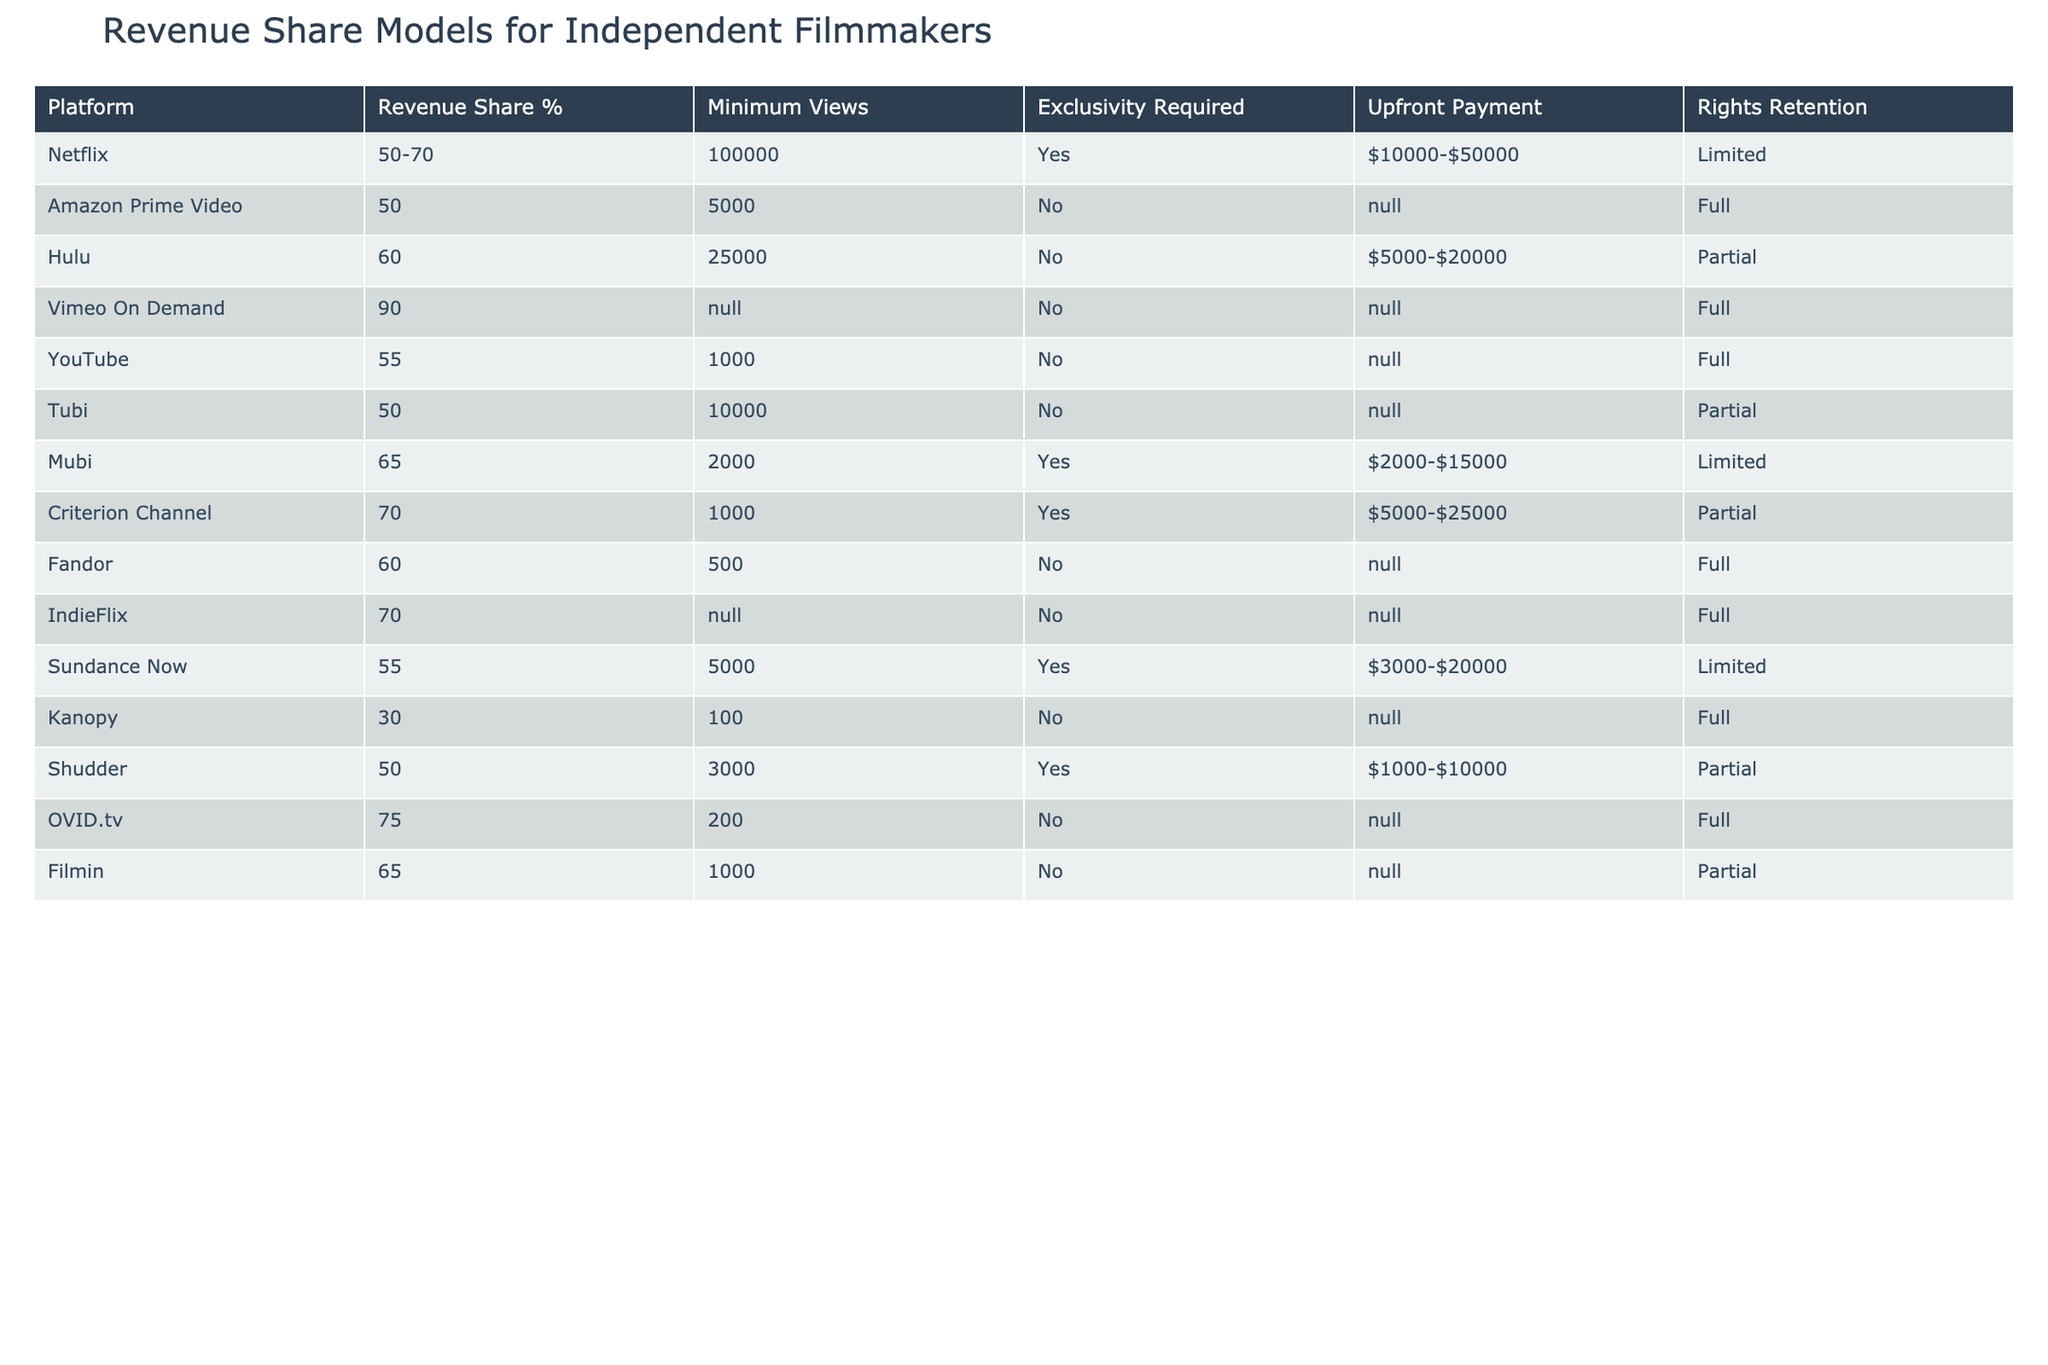What is the revenue share percentage for Vimeo On Demand? In the table, I look for the row that corresponds to Vimeo On Demand and find the "Revenue Share %" column. It shows 90%.
Answer: 90% Is there a platform that offers a revenue share of 70%? By scanning through the "Revenue Share %" column, I see that both Netflix and IndieFlix offer a revenue share of 70%.
Answer: Yes Which platform requires exclusivity for revenue sharing? I check the "Exclusivity Required" column for all platforms. The platforms that have 'Yes' listed there are Netflix, Mubi, Criterion Channel, and Sundance Now.
Answer: Netflix, Mubi, Criterion Channel, Sundance Now What is the minimum number of views required on YouTube for revenue sharing? Looking at YouTube's row in the table, the "Minimum Views" column shows 1000 views are required.
Answer: 1000 Are there any platforms that provide full rights retention to filmmakers? I examine the "Rights Retention" column and find that Amazon Prime Video, Vimeo On Demand, YouTube, Fandor, and IndieFlix all have 'Full' listed as their rights retention policy.
Answer: Yes What is the average revenue share percentage of platforms that do not require exclusivity? I identify the platforms not requiring exclusivity: Amazon Prime Video (50%), Hulu (60%), Vimeo On Demand (90%), YouTube (55%), Tubi (50%), Fandor (60%), IndieFlix (70%), and Kanopy (30%). I sum these percentages: 50 + 60 + 90 + 55 + 50 + 60 + 70 + 30 = 415. There are 8 platforms, so the average is 415/8 = 51.875, which rounds to 52%.
Answer: 52% How many platforms have a minimum view count of 5,000 or more? I count the platforms with "Minimum Views" equal to or exceeding 5,000. These are Netflix (100,000), Hulu (25,000), Amazon Prime Video (5,000), Mubi (2,000), Sundance Now (5,000), Shudder (3,000). Adding these gives 6 platforms.
Answer: 6 Which platform offers the highest upfront payment to filmmakers? In the "Upfront Payment" column, I compare all values and determine that Netflix offers $10,000-$50,000, while Criterion Channel has $5,000-$25,000. The highest range belongs to Netflix.
Answer: Netflix Is there any platform that does not require any minimum views for revenue sharing? Looking at the "Minimum Views" column, I find that both Vimeo On Demand and IndieFlix have 'None' specified, which means no minimum views are required.
Answer: Yes What is the difference in revenue share percentage between the highest and the lowest platform? The highest revenue share percentage is 90% (Vimeo On Demand) and the lowest is 30% (Kanopy). The difference is 90 - 30 = 60%.
Answer: 60% What percentage of platforms require an upfront payment? I scan through the "Upfront Payment" column and see that 6 out of 12 platforms list specific upfront payment ranges (i.e., Netflix, Hulu, Mubi, Sundance Now, Shudder). To find the percentage, I calculate (6/12) * 100, which equals 50%.
Answer: 50% 